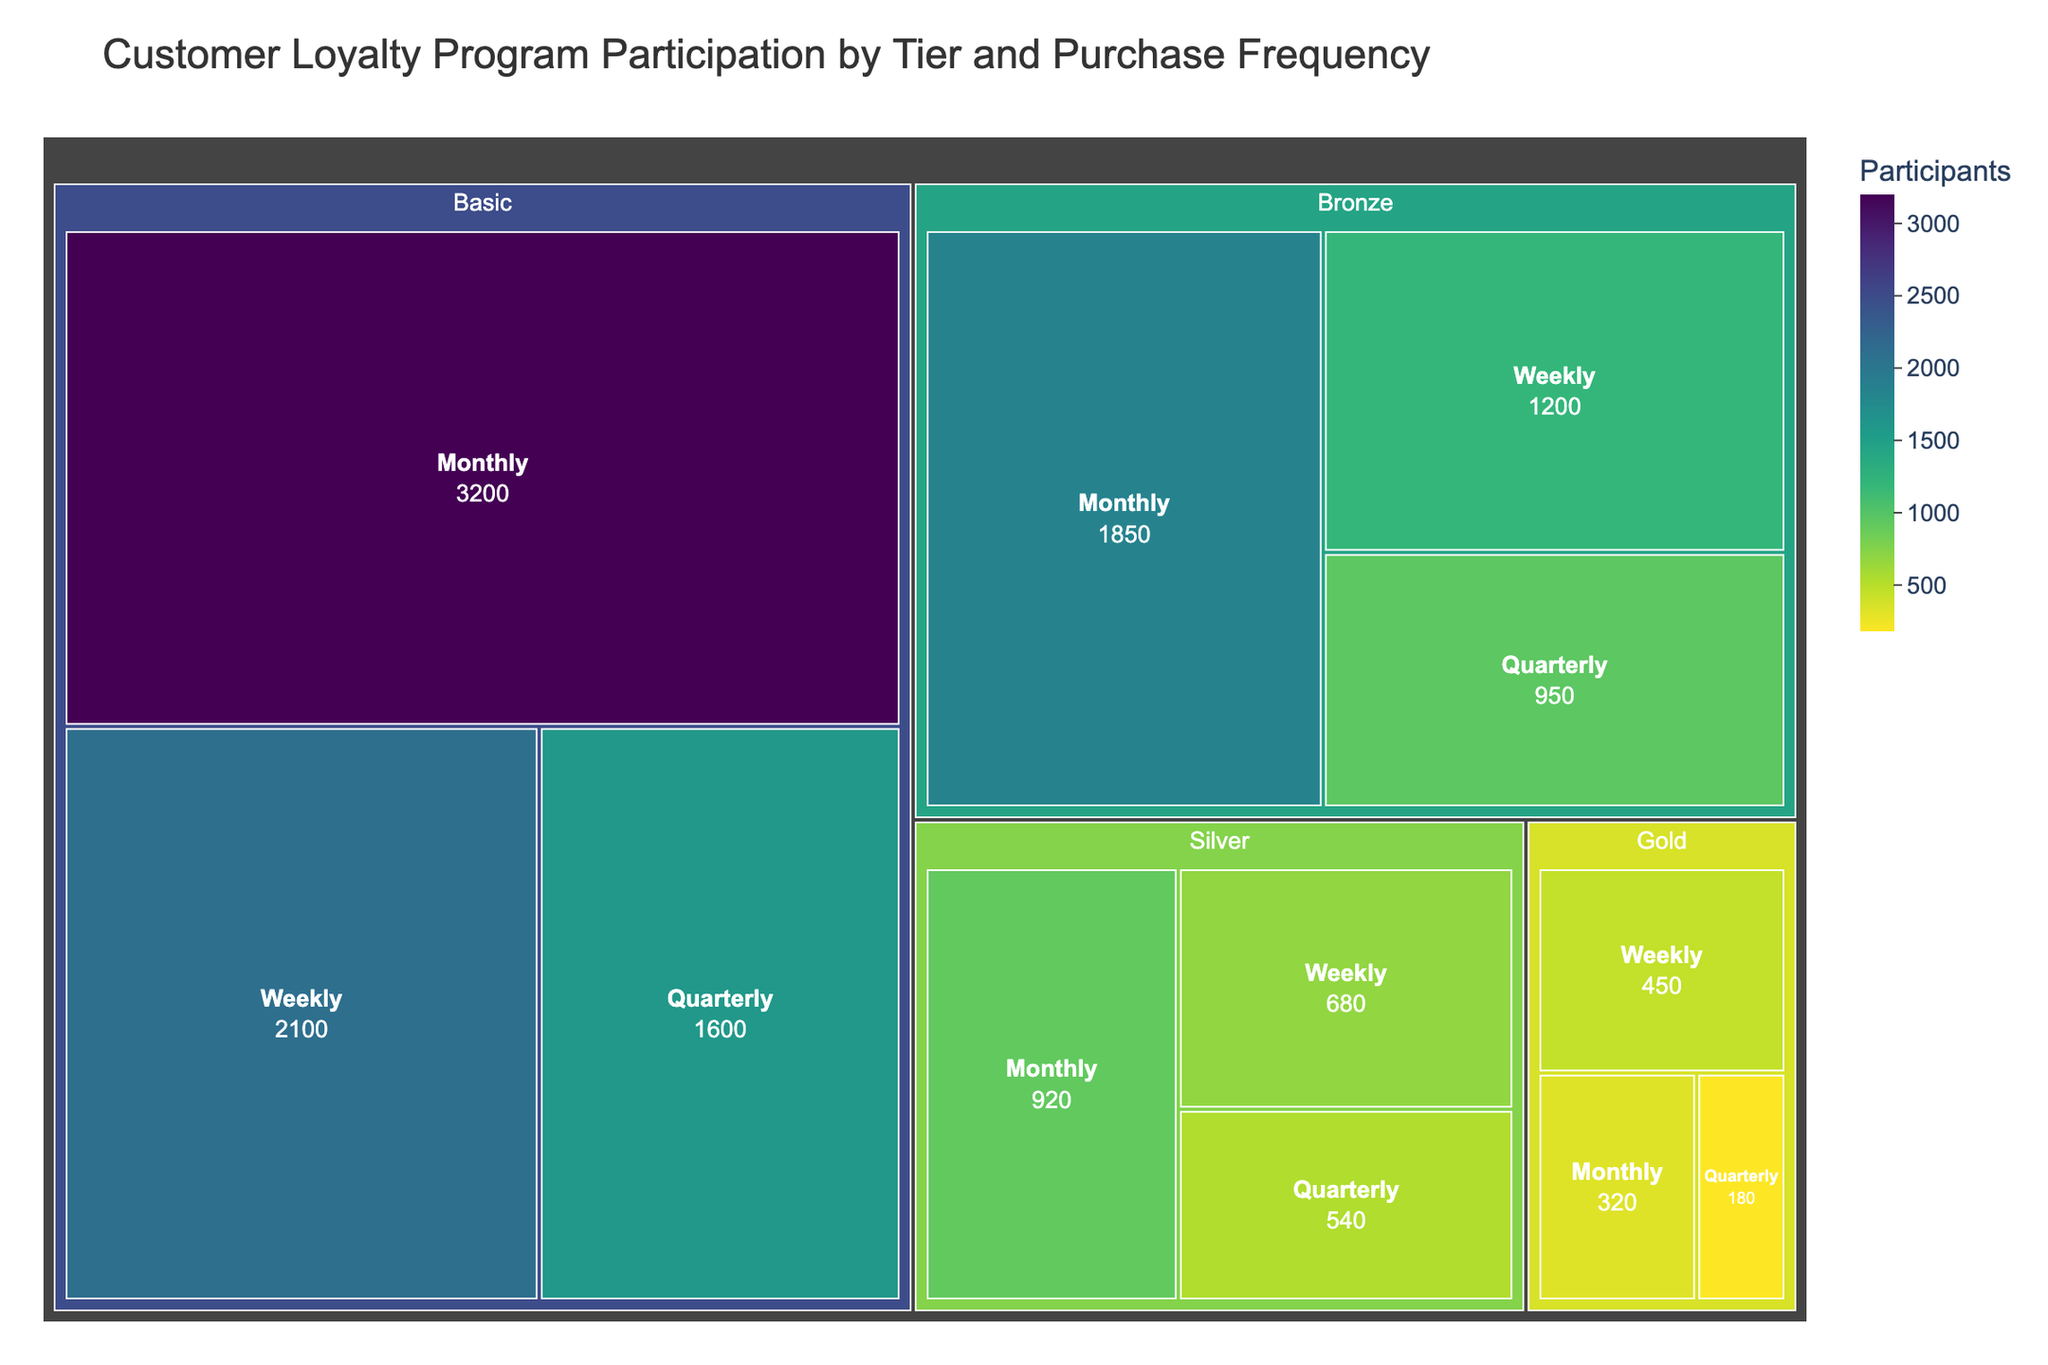What's the title of the figure? The title is at the top of the figure and is usually in a larger font size compared to other text elements. It helps give context to what the figure is about. It reads: "Customer Loyalty Program Participation by Tier and Purchase Frequency."
Answer: Customer Loyalty Program Participation by Tier and Purchase Frequency Which tier has the highest number of participants? In a treemap, larger rectangles represent higher values. The "Basic" tier has the largest rectangles, indicating that it has the highest number of participants.
Answer: Basic What's the total number of participants in the "Gold" tier? Sum the participants in each purchase frequency category under the "Gold" tier: 450 (Weekly) + 320 (Monthly) + 180 (Quarterly). The total is 450 + 320 + 180 = 950.
Answer: 950 Which purchase frequency has the most participants in the "Silver" tier? Compare the sizes of the rectangles under the "Silver" tier. The largest rectangle represents the purchase frequency with the most participants. "Monthly" has the largest rectangle in this tier.
Answer: Monthly How many more participants are there in the "Weekly" purchase frequency of the "Bronze" tier compared to the "Gold" tier? Subtract the number of "Weekly" participants in the "Gold" tier from those in the "Bronze" tier. It's 1200 (Bronze) - 450 (Gold) = 750.
Answer: 750 What's the proportion of "Quarterly" participants in the "Basic" tier relative to the total participants in that tier? First, find the total number of participants in the "Basic" tier: 2100 (Weekly) + 3200 (Monthly) + 1600 (Quarterly) = 6900. Then calculate the proportion for the "Quarterly" participants, which is 1600 / 6900 ≈ 0.232.
Answer: ~0.232 Compare the number of "Monthly" and "Quarterly" participants in the "Bronze" tier. Which has more, and by how much? Subtract the number of "Quarterly" participants from the "Monthly" participants in the "Bronze" tier: 1850 - 950 = 900. "Monthly" has more participants by 900.
Answer: Monthly, by 900 Does any tier have an equal number of participants in more than one purchase frequency category? Inspect each tier to see if any category has equal values. None of the tiers have two purchase frequency categories with identical numbers of participants.
Answer: No What is the average number of participants in the "Silver" tier across all purchase frequencies? Sum the participants in all frequencies and divide by the number of frequencies. (680 + 920 + 540) / 3 = 2140 / 3 ≈ 713.33.
Answer: ~713.33 Which purchase frequency generally has the lowest number of participants across all tiers? By looking at the treemap and comparing the sizes of the rectangles across all tiers, the "Quarterly" purchase frequency generally seems to have the smallest rectangles, indicating the lowest number of participants.
Answer: Quarterly 